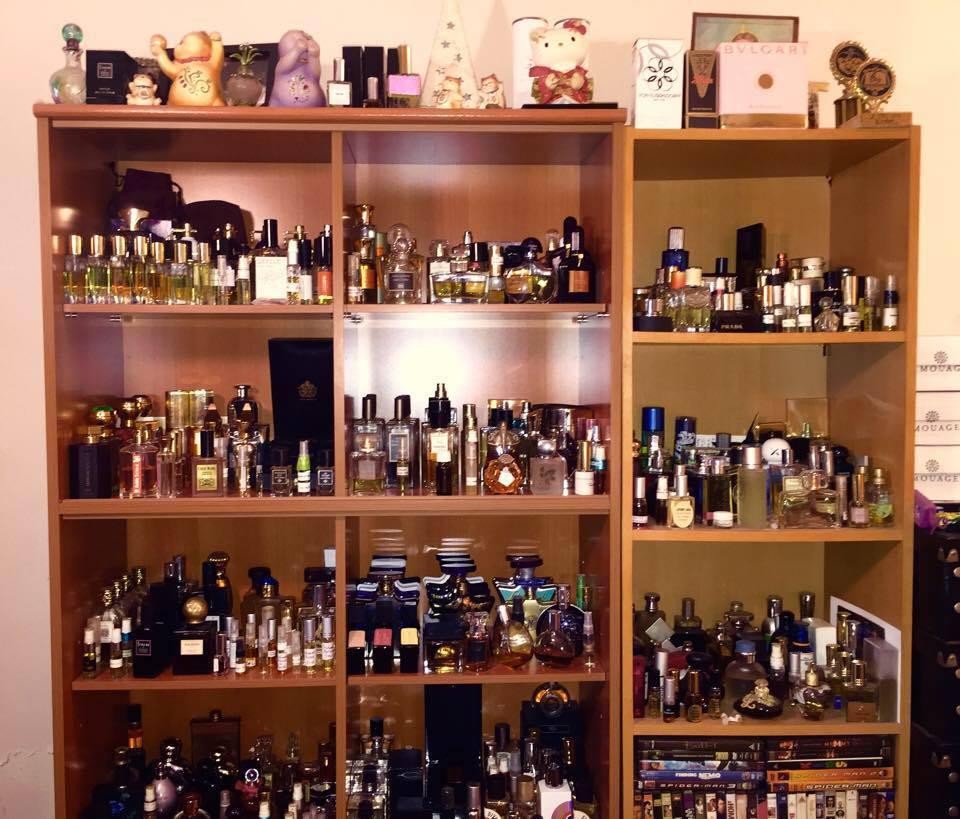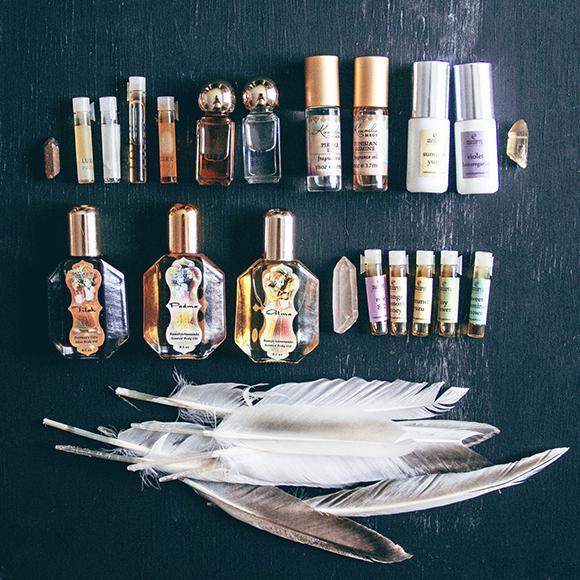The first image is the image on the left, the second image is the image on the right. Given the left and right images, does the statement "There are at least ten perfumes in the left image." hold true? Answer yes or no. Yes. The first image is the image on the left, the second image is the image on the right. Examine the images to the left and right. Is the description "The left image shows one glass fragrance bottle in a reflective glass display, and the right image shows a white shelf that angles up to the right and holds fragrance bottles." accurate? Answer yes or no. No. 